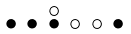Convert formula to latex. <formula><loc_0><loc_0><loc_500><loc_500>\begin{smallmatrix} & & \circ \\ \bullet & \bullet & \bullet & \circ & \circ & \bullet & \\ \end{smallmatrix}</formula> 